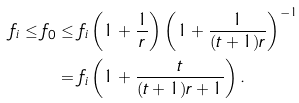<formula> <loc_0><loc_0><loc_500><loc_500>f _ { i } \leq f _ { 0 } & \leq f _ { i } \left ( 1 + \frac { 1 } { r } \right ) \left ( 1 + \frac { 1 } { ( t + 1 ) r } \right ) ^ { - 1 } \\ & = f _ { i } \left ( 1 + \frac { t } { ( t + 1 ) r + 1 } \right ) .</formula> 